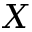<formula> <loc_0><loc_0><loc_500><loc_500>X</formula> 